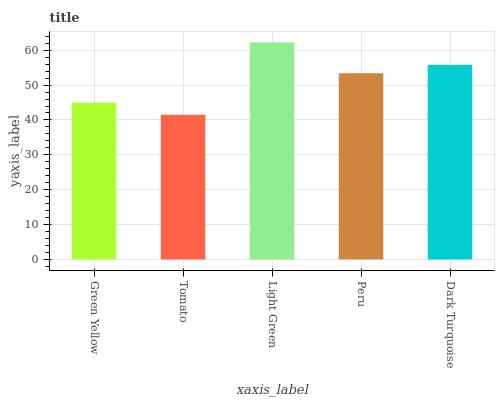Is Tomato the minimum?
Answer yes or no. Yes. Is Light Green the maximum?
Answer yes or no. Yes. Is Light Green the minimum?
Answer yes or no. No. Is Tomato the maximum?
Answer yes or no. No. Is Light Green greater than Tomato?
Answer yes or no. Yes. Is Tomato less than Light Green?
Answer yes or no. Yes. Is Tomato greater than Light Green?
Answer yes or no. No. Is Light Green less than Tomato?
Answer yes or no. No. Is Peru the high median?
Answer yes or no. Yes. Is Peru the low median?
Answer yes or no. Yes. Is Dark Turquoise the high median?
Answer yes or no. No. Is Light Green the low median?
Answer yes or no. No. 